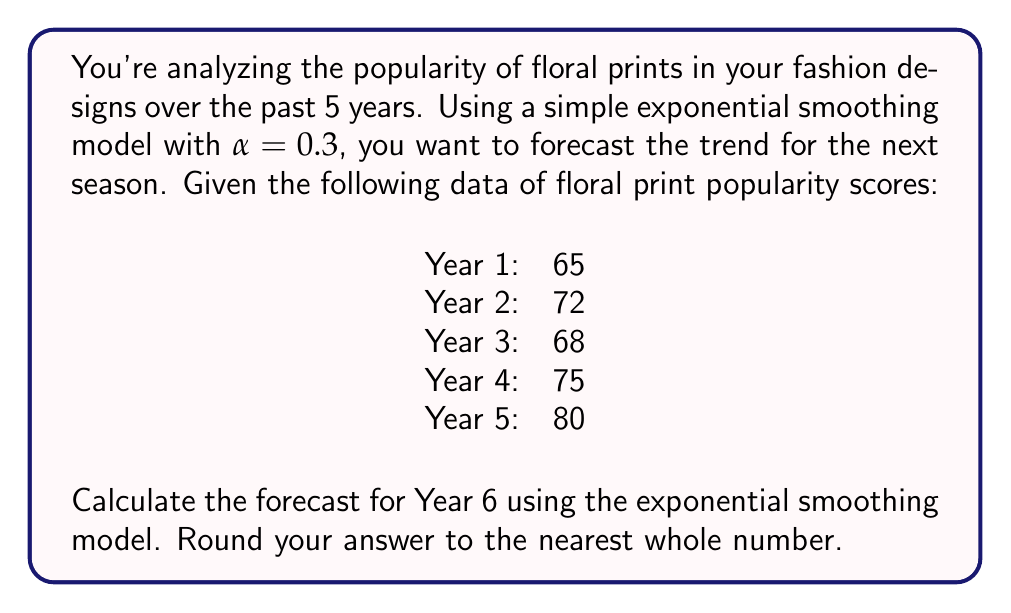Give your solution to this math problem. To solve this problem, we'll use the simple exponential smoothing model, which is a time series forecasting technique. The formula for this model is:

$$F_{t+1} = \alpha Y_t + (1-\alpha)F_t$$

Where:
$F_{t+1}$ is the forecast for the next period
$\alpha$ is the smoothing factor (given as 0.3)
$Y_t$ is the actual value for the current period
$F_t$ is the forecast for the current period

Let's calculate the forecasts step by step:

1. For Year 1, we don't have a previous forecast, so we'll use the actual value as our first forecast:
   $F_1 = 65$

2. For Year 2:
   $F_2 = 0.3 * 65 + (1-0.3) * 65 = 65$

3. For Year 3:
   $F_3 = 0.3 * 72 + (1-0.3) * 65 = 67.1$

4. For Year 4:
   $F_4 = 0.3 * 68 + (1-0.3) * 67.1 = 67.37$

5. For Year 5:
   $F_5 = 0.3 * 75 + (1-0.3) * 67.37 = 69.659$

6. Finally, for Year 6 (our forecast):
   $F_6 = 0.3 * 80 + (1-0.3) * 69.659 = 72.7613$

Rounding to the nearest whole number, we get 73.
Answer: 73 